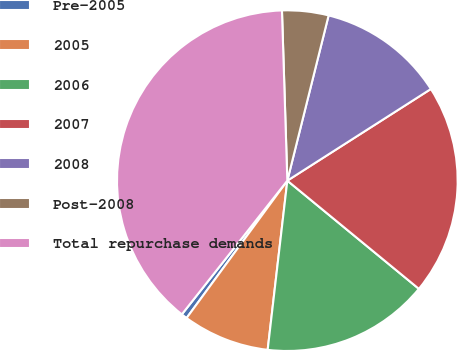Convert chart to OTSL. <chart><loc_0><loc_0><loc_500><loc_500><pie_chart><fcel>Pre-2005<fcel>2005<fcel>2006<fcel>2007<fcel>2008<fcel>Post-2008<fcel>Total repurchase demands<nl><fcel>0.56%<fcel>8.23%<fcel>15.89%<fcel>20.0%<fcel>12.06%<fcel>4.4%<fcel>38.87%<nl></chart> 